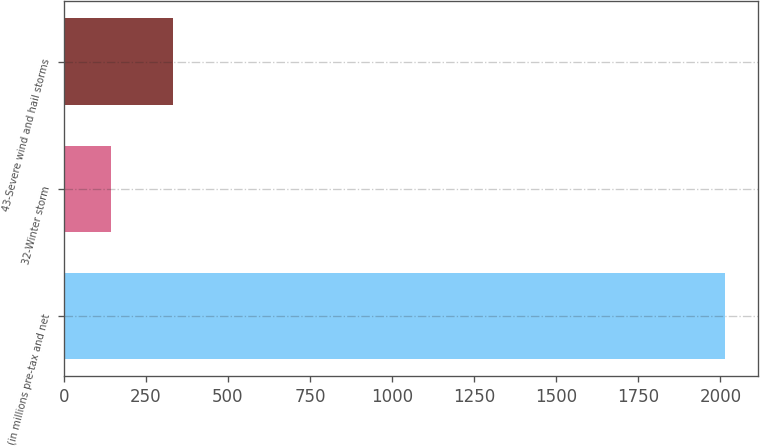<chart> <loc_0><loc_0><loc_500><loc_500><bar_chart><fcel>(in millions pre-tax and net<fcel>32-Winter storm<fcel>43-Severe wind and hail storms<nl><fcel>2014<fcel>144<fcel>331<nl></chart> 